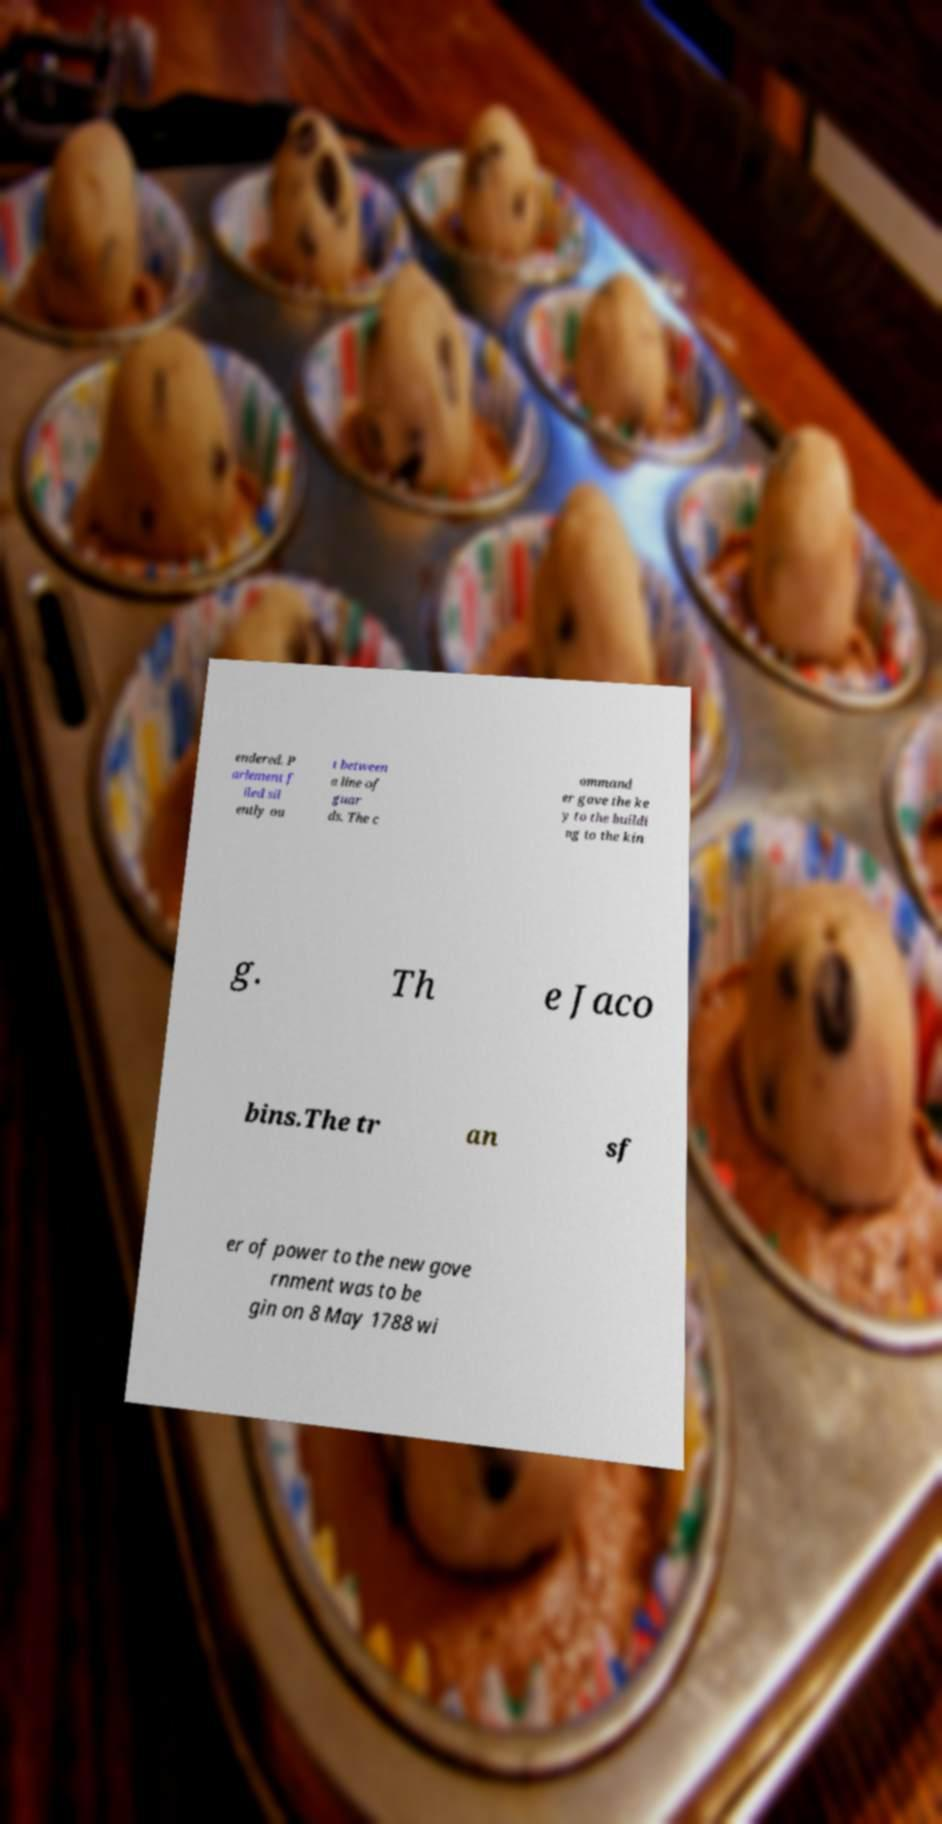I need the written content from this picture converted into text. Can you do that? endered. P arlement f iled sil ently ou t between a line of guar ds. The c ommand er gave the ke y to the buildi ng to the kin g. Th e Jaco bins.The tr an sf er of power to the new gove rnment was to be gin on 8 May 1788 wi 